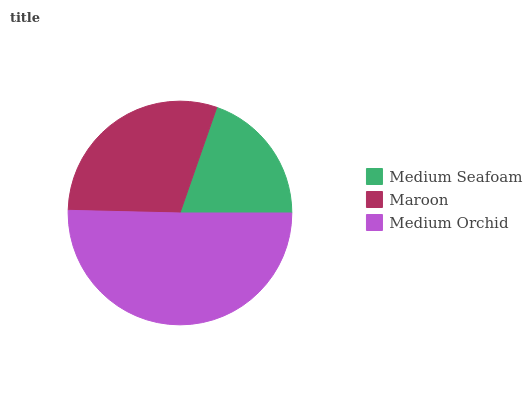Is Medium Seafoam the minimum?
Answer yes or no. Yes. Is Medium Orchid the maximum?
Answer yes or no. Yes. Is Maroon the minimum?
Answer yes or no. No. Is Maroon the maximum?
Answer yes or no. No. Is Maroon greater than Medium Seafoam?
Answer yes or no. Yes. Is Medium Seafoam less than Maroon?
Answer yes or no. Yes. Is Medium Seafoam greater than Maroon?
Answer yes or no. No. Is Maroon less than Medium Seafoam?
Answer yes or no. No. Is Maroon the high median?
Answer yes or no. Yes. Is Maroon the low median?
Answer yes or no. Yes. Is Medium Seafoam the high median?
Answer yes or no. No. Is Medium Orchid the low median?
Answer yes or no. No. 